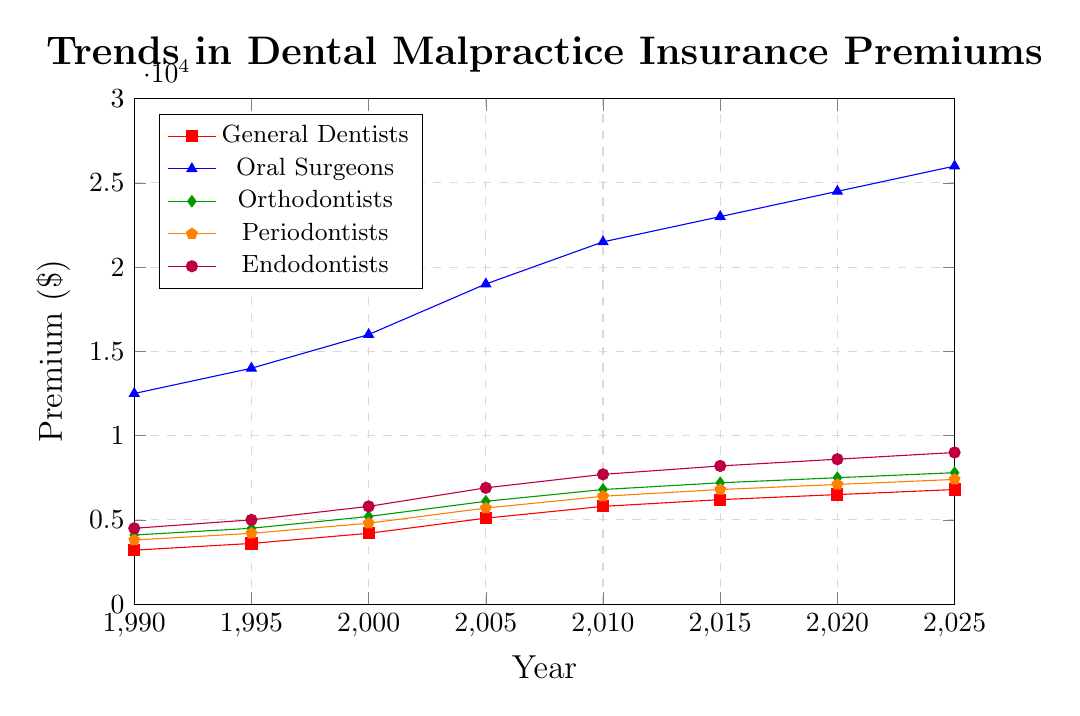Which specialist had the highest malpractice insurance premium in 1990? Looking at the plot, in 1990 Oral Surgeons had the highest premiums.
Answer: Oral Surgeons Which type of dentist saw the smallest increase in malpractice insurance premiums from 2010 to 2025? By comparing the premiums of each type in 2010 and 2025, Orthodontists had the smallest increase from $6800 to $7800.
Answer: Orthodontists Which group has the highest increase in premiums from 1990 to 2025? Oral Surgeons’ premiums increased from $12,500 in 1990 to $26,000 in 2025, the largest increase among the groups.
Answer: Oral Surgeons What is the average premium for General Dentists over the entire period? The premiums for General Dentists over the years are $3200, $3600, $4200, $5100, $5800, $6200, $6500, and $6800. The average is calculated as (3200 + 3600 + 4200 + 5100 + 5800 + 6200 + 6500 + 6800)/8 = $5175.
Answer: $5175 How does the premium for Endodontists in 2000 compare to the premium for Oral Surgeons in 1995? The premium for Endodontists in 2000 is $5800, while for Oral Surgeons in 1995, it is $14,000. $5800 is less than $14,000.
Answer: Less than Between what years did Periodontists see the highest rate of increase in premiums? By comparing consecutive intervals, the highest rate of increase for Periodontists occurred from 2000 ($4800) to 2005 ($5700), with an increase of $900.
Answer: 2000 to 2005 Are the premiums for Orthodontists higher in 2020 than for General Dentists in 2025? Comparing the values in the plot, Orthodontists in 2020 have premiums of $7200, whereas General Dentists in 2025 have premiums of $6800. Yes, $7200 is higher than $6800.
Answer: Yes What is the approximate difference in premiums between General Dentists and Oral Surgeons in 2025? The premiums for General Dentists in 2025 are $6800, and for Oral Surgeons, it is $26000. The difference is $26000 - $6800 = $19200.
Answer: $19200 What is the median premium for Periodontists over the given years? The premiums for Periodontists are $3800, $4200, $4800, $5700, $6400, $6800, $7100, and $7400. Ordering these: $3800, $4200, $4800, $5700, $6400, $6800, $7100, $7400. The median value (average of 4th and 5th) is ($5700+$6400)/2 = $6050.
Answer: $6050 Which two types of dentists had the closest premiums in 2005? In 2005, comparing General Dentists ($5100), Oral Surgeons ($19000), Orthodontists ($6100), Periodontists ($5700), and Endodontists ($6900), General Dentists and Periodontists had the closest premiums of $5100 and $5700.
Answer: General Dentists and Periodontists 